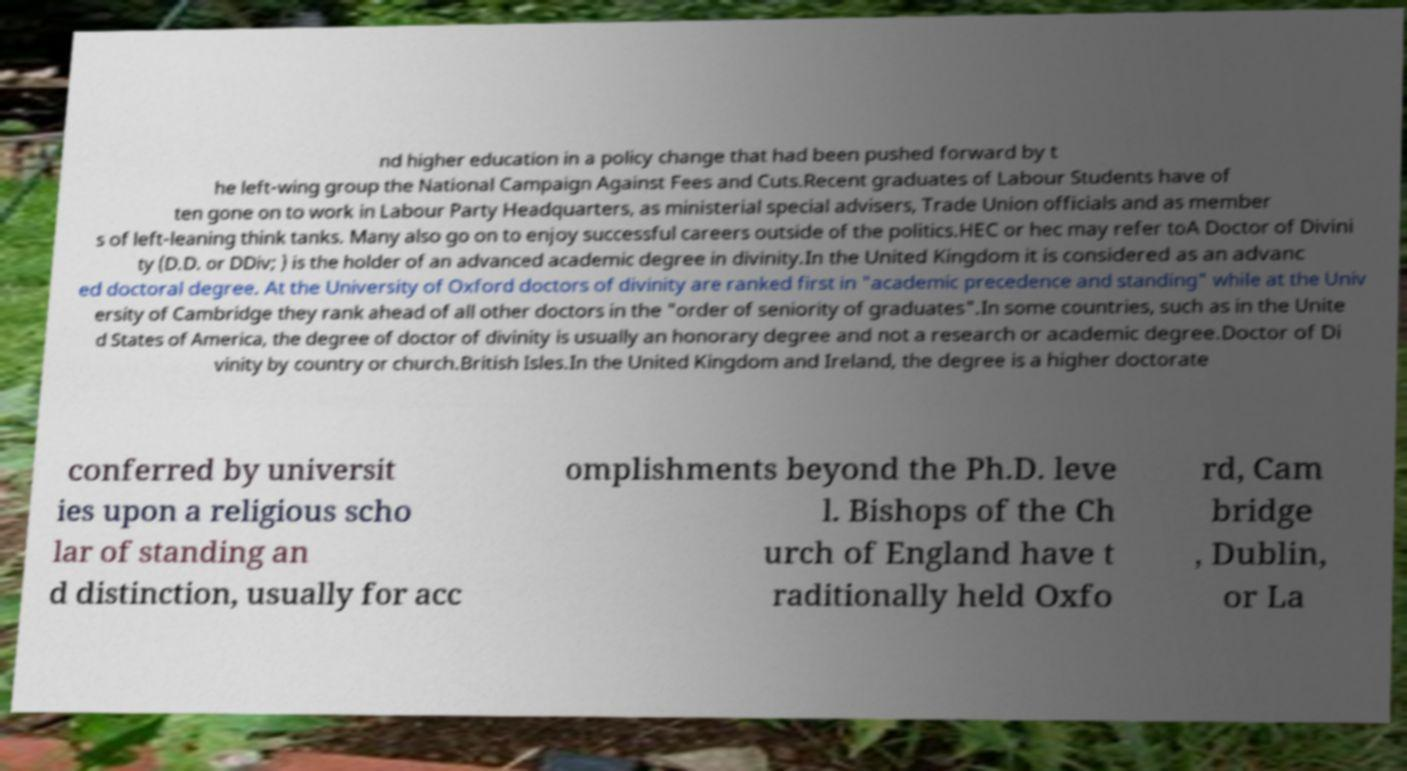Please identify and transcribe the text found in this image. nd higher education in a policy change that had been pushed forward by t he left-wing group the National Campaign Against Fees and Cuts.Recent graduates of Labour Students have of ten gone on to work in Labour Party Headquarters, as ministerial special advisers, Trade Union officials and as member s of left-leaning think tanks. Many also go on to enjoy successful careers outside of the politics.HEC or hec may refer toA Doctor of Divini ty (D.D. or DDiv; ) is the holder of an advanced academic degree in divinity.In the United Kingdom it is considered as an advanc ed doctoral degree. At the University of Oxford doctors of divinity are ranked first in "academic precedence and standing" while at the Univ ersity of Cambridge they rank ahead of all other doctors in the "order of seniority of graduates".In some countries, such as in the Unite d States of America, the degree of doctor of divinity is usually an honorary degree and not a research or academic degree.Doctor of Di vinity by country or church.British Isles.In the United Kingdom and Ireland, the degree is a higher doctorate conferred by universit ies upon a religious scho lar of standing an d distinction, usually for acc omplishments beyond the Ph.D. leve l. Bishops of the Ch urch of England have t raditionally held Oxfo rd, Cam bridge , Dublin, or La 